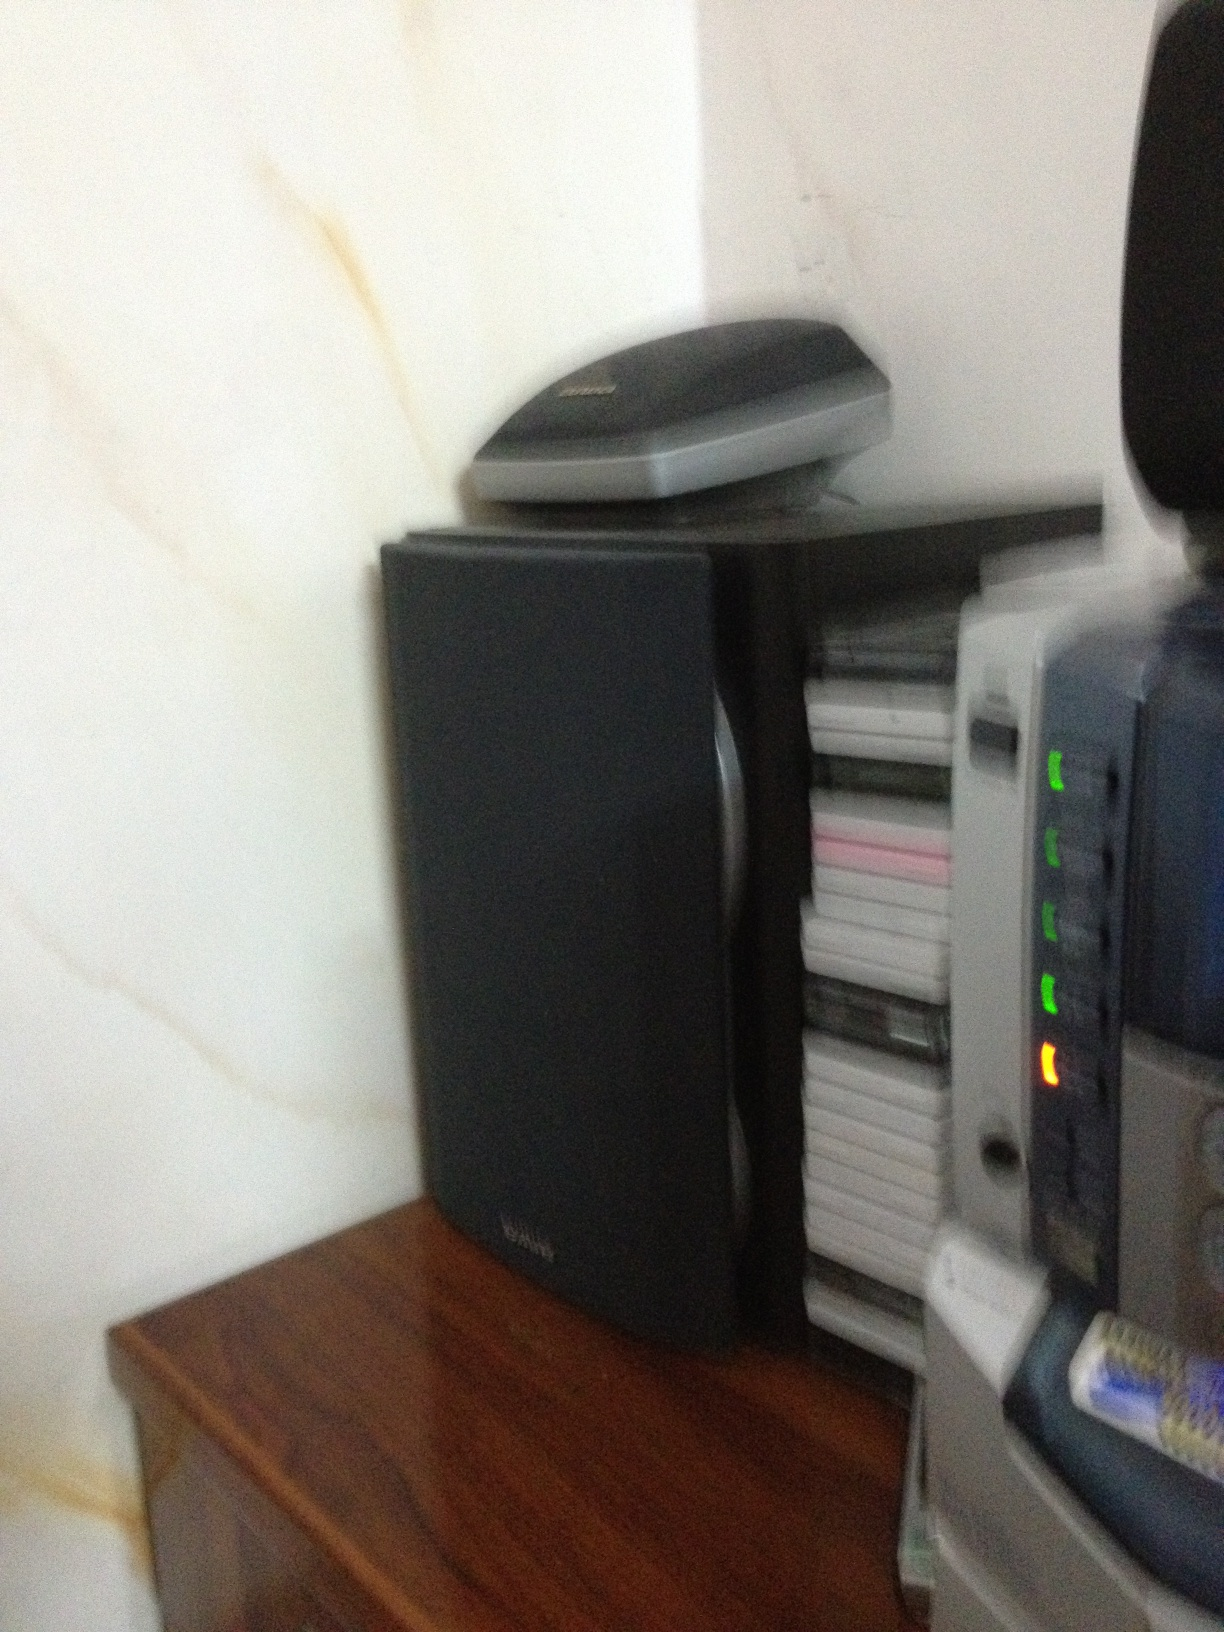Is this a book? No, the image does not show a book. It appears to be a collection of electronic devices, such as a speaker and other equipment, probably indicating an entertainment or audio setup. 